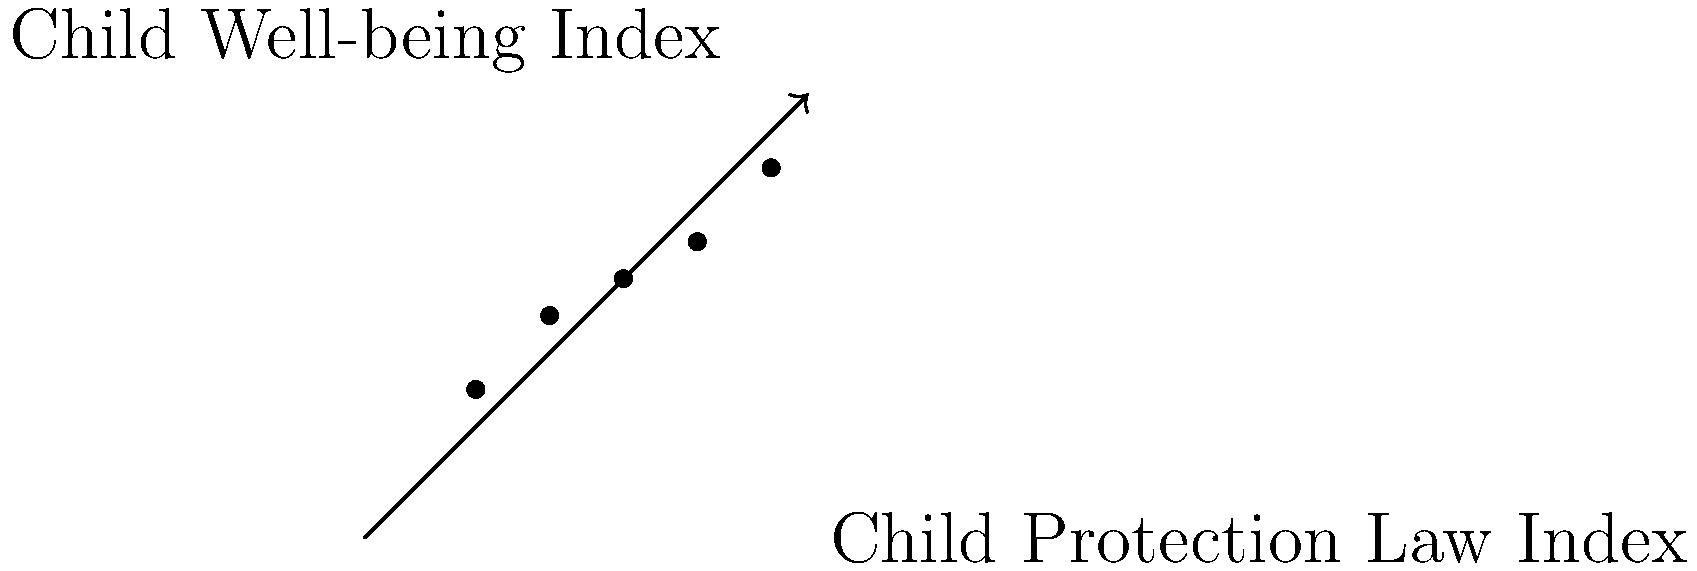Based on the scatter plot showing the relationship between the Child Protection Law Index and Child Well-being Index across different countries, what can be inferred about the correlation between child protection laws and child well-being indicators? To analyze the correlation between child protection laws and child well-being indicators, we need to examine the scatter plot:

1. Observe the general trend: The points seem to form an upward sloping pattern from left to right.

2. Positive correlation: As the Child Protection Law Index increases along the x-axis, the Child Well-being Index tends to increase along the y-axis.

3. Strength of correlation: The points are relatively close to forming a straight line, suggesting a moderately strong positive correlation.

4. Linear relationship: The relationship appears to be approximately linear, as the points don't form any obvious curves or clusters.

5. Outliers: There don't appear to be any significant outliers that deviate from the general trend.

6. Interpretation: Countries with stronger child protection laws (higher Child Protection Law Index) tend to have better child well-being outcomes (higher Child Well-being Index).

7. Causation vs. correlation: While there is a positive correlation, we cannot conclude causation from this data alone. Other factors may influence both variables.

Based on these observations, we can infer that there is a positive correlation between child protection laws and child well-being indicators.
Answer: Positive correlation 